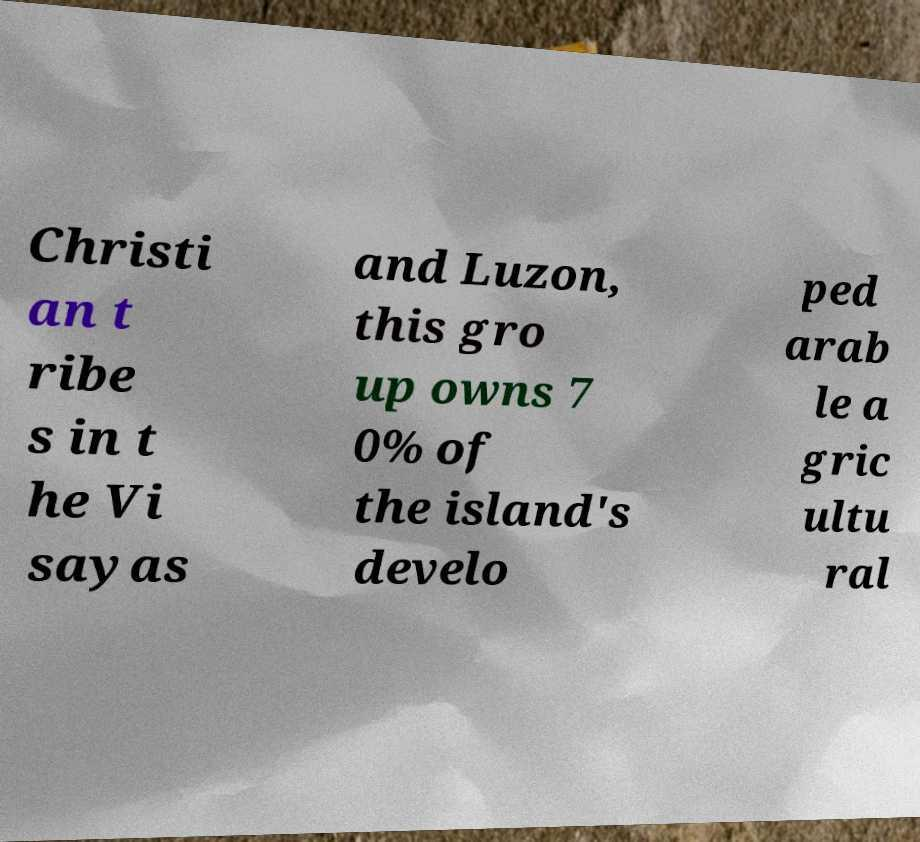What messages or text are displayed in this image? I need them in a readable, typed format. Christi an t ribe s in t he Vi sayas and Luzon, this gro up owns 7 0% of the island's develo ped arab le a gric ultu ral 